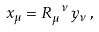<formula> <loc_0><loc_0><loc_500><loc_500>x _ { \mu } = R _ { \mu } ^ { \ \nu } \, y _ { \nu } \, ,</formula> 